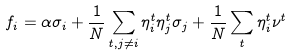<formula> <loc_0><loc_0><loc_500><loc_500>f _ { i } = \alpha \sigma _ { i } + \frac { 1 } { N } \sum _ { t , j \neq i } \eta _ { i } ^ { t } \eta _ { j } ^ { t } \sigma _ { j } + \frac { 1 } { N } \sum _ { t } \eta _ { i } ^ { t } \nu ^ { t }</formula> 